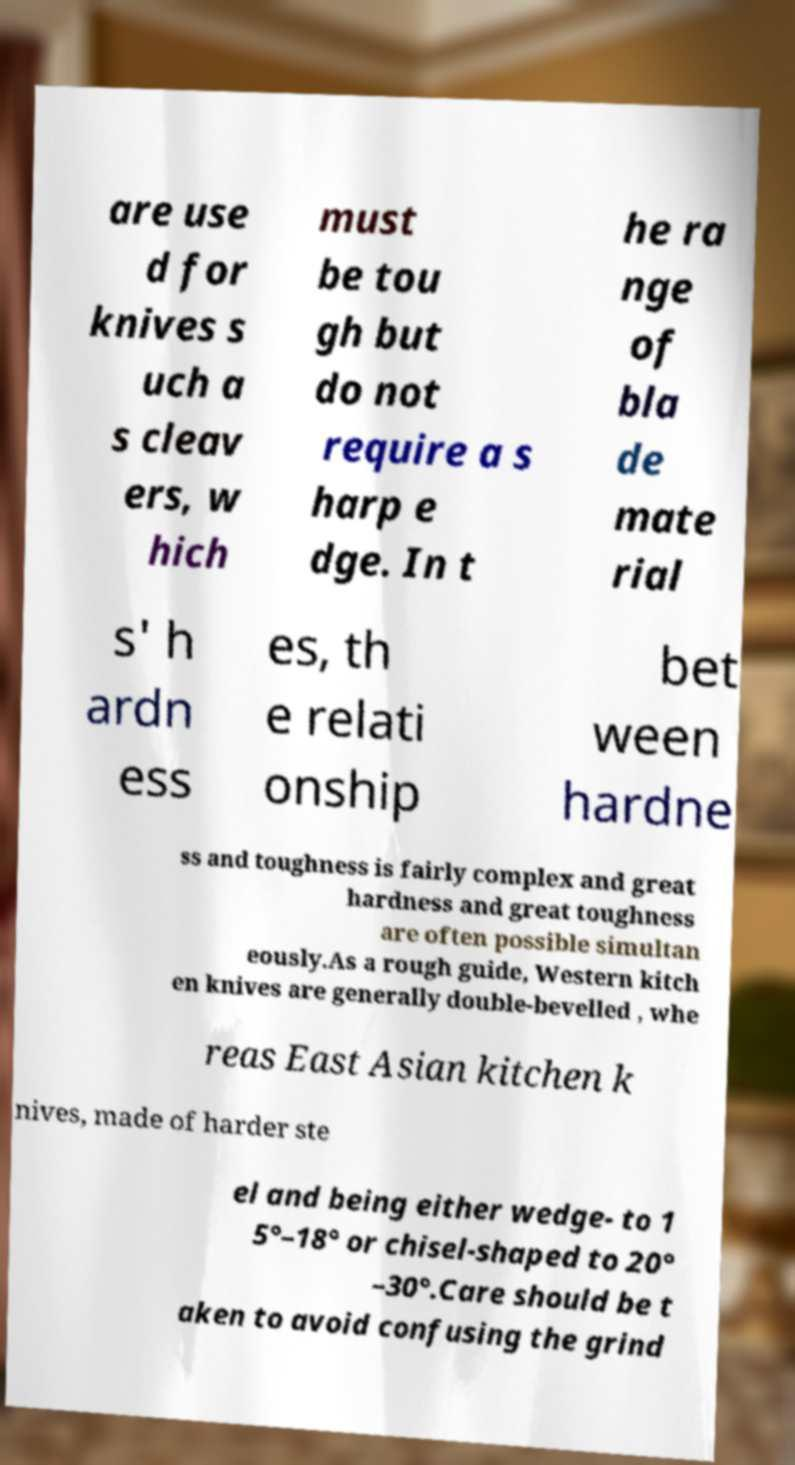What messages or text are displayed in this image? I need them in a readable, typed format. are use d for knives s uch a s cleav ers, w hich must be tou gh but do not require a s harp e dge. In t he ra nge of bla de mate rial s' h ardn ess es, th e relati onship bet ween hardne ss and toughness is fairly complex and great hardness and great toughness are often possible simultan eously.As a rough guide, Western kitch en knives are generally double-bevelled , whe reas East Asian kitchen k nives, made of harder ste el and being either wedge- to 1 5°–18° or chisel-shaped to 20° –30°.Care should be t aken to avoid confusing the grind 